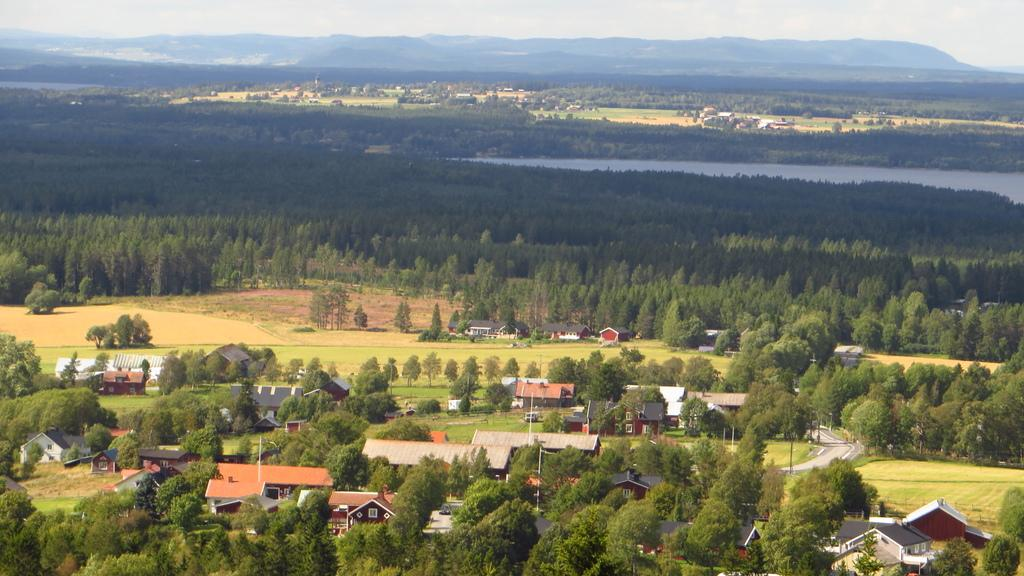What type of vegetation is present in the image? There are many trees in the image. What type of structures can be seen in the image? There are houses in the image. What can be seen in the distance in the background of the image? There is water, more trees, houses, mountains, and the sky visible in the background of the image. What is the cow writing on the paper in the image? There is no cow or paper present in the image. 